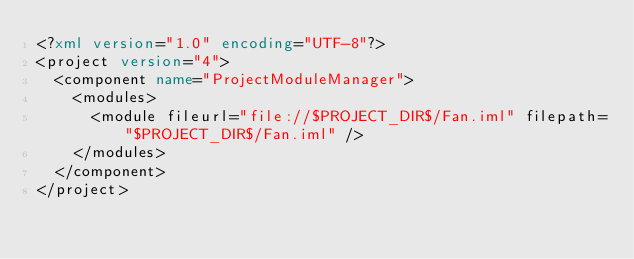<code> <loc_0><loc_0><loc_500><loc_500><_XML_><?xml version="1.0" encoding="UTF-8"?>
<project version="4">
  <component name="ProjectModuleManager">
    <modules>
      <module fileurl="file://$PROJECT_DIR$/Fan.iml" filepath="$PROJECT_DIR$/Fan.iml" />
    </modules>
  </component>
</project></code> 